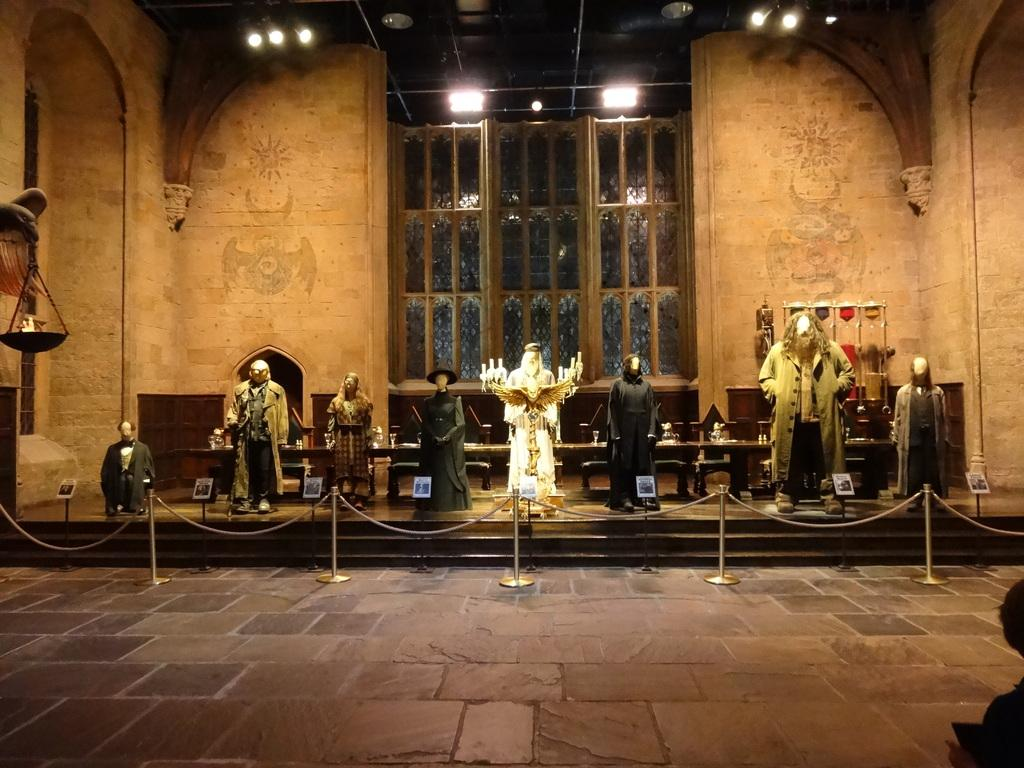What type of figures can be seen in the image? There are mannequins in the image. What piece of furniture is present in the image? There is a table in the image. What type of seating is visible in the image? There are chairs in the image. What part of the room can be seen in the image? The floor is visible in the image. What can be seen in the background of the image? There are windows, a wall, and lights in the background of the image. What type of coal is being used to fuel the knee in the image? There is no coal or knee present in the image; it features mannequins, a table, chairs, and other elements of a room. 